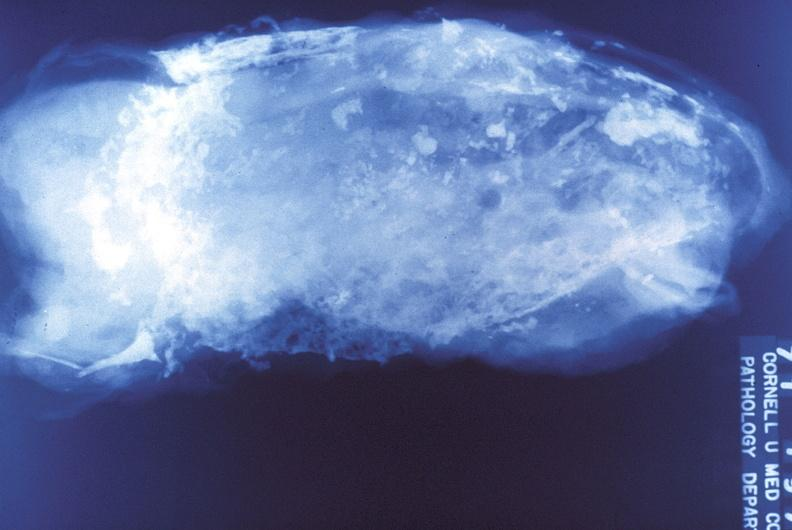does this image show tuberculosis, empyema?
Answer the question using a single word or phrase. Yes 